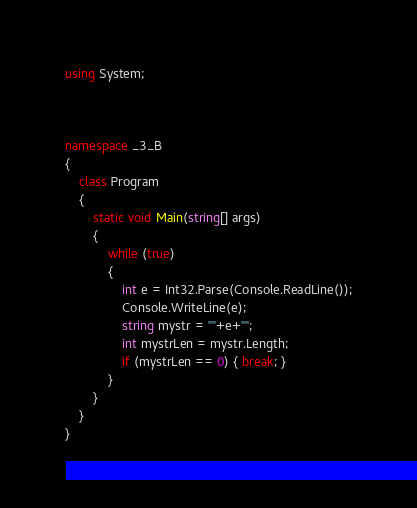<code> <loc_0><loc_0><loc_500><loc_500><_C#_>using System;



namespace _3_B
{
    class Program
    {
        static void Main(string[] args)
        {
            while (true)
            {
                int e = Int32.Parse(Console.ReadLine());
                Console.WriteLine(e);
                string mystr = ""+e+"";
                int mystrLen = mystr.Length;
                if (mystrLen == 0) { break; }
            }
        }
    }
}</code> 